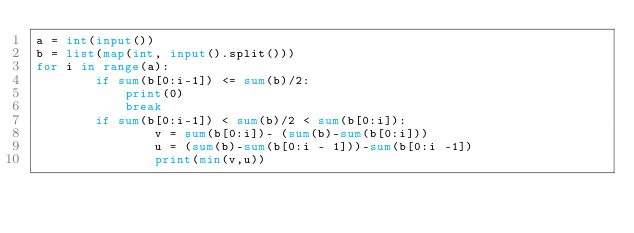<code> <loc_0><loc_0><loc_500><loc_500><_Python_>a = int(input())
b = list(map(int, input().split()))
for i in range(a):
        if sum(b[0:i-1]) <= sum(b)/2:
            print(0)
            break
        if sum(b[0:i-1]) < sum(b)/2 < sum(b[0:i]):
                v = sum(b[0:i])- (sum(b)-sum(b[0:i]))
                u = (sum(b)-sum(b[0:i - 1]))-sum(b[0:i -1])
                print(min(v,u))</code> 